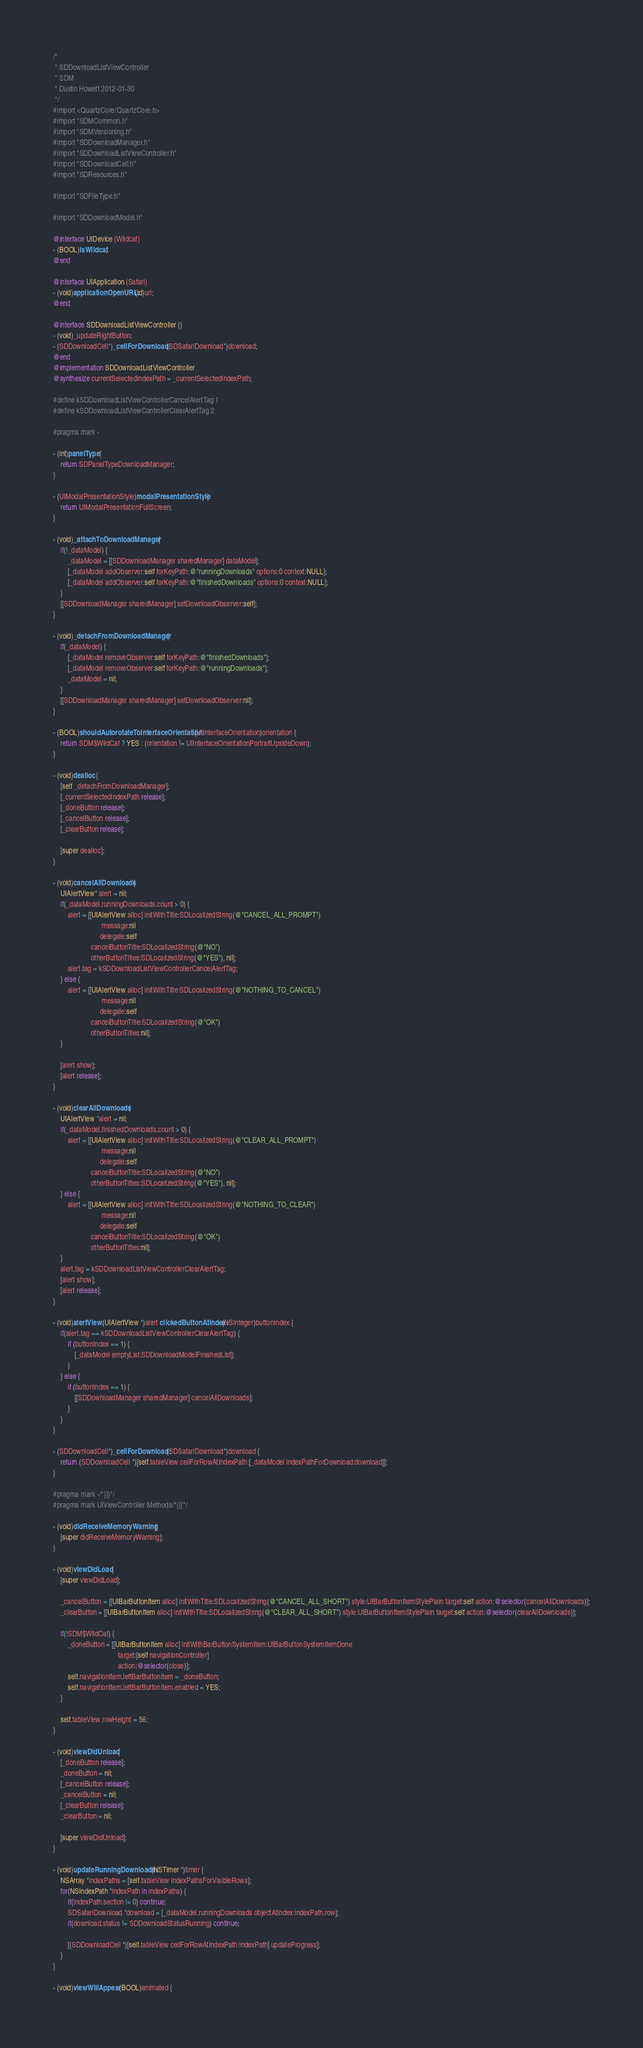Convert code to text. <code><loc_0><loc_0><loc_500><loc_500><_ObjectiveC_>/*
 * SDDownloadListViewController
 * SDM
 * Dustin Howett 2012-01-30
 */
#import <QuartzCore/QuartzCore.h>
#import "SDMCommon.h"
#import "SDMVersioning.h"
#import "SDDownloadManager.h"
#import "SDDownloadListViewController.h"
#import "SDDownloadCell.h"
#import "SDResources.h"

#import "SDFileType.h"

#import "SDDownloadModel.h"

@interface UIDevice (Wildcat)
- (BOOL)isWildcat;
@end

@interface UIApplication (Safari)
- (void)applicationOpenURL:(id)url;
@end

@interface SDDownloadListViewController ()
- (void)_updateRightButton;
- (SDDownloadCell*)_cellForDownload:(SDSafariDownload*)download;
@end
@implementation SDDownloadListViewController
@synthesize currentSelectedIndexPath = _currentSelectedIndexPath;

#define kSDDownloadListViewControllerCancelAlertTag 1
#define kSDDownloadListViewControllerClearAlertTag 2

#pragma mark -

- (int)panelType {
	return SDPanelTypeDownloadManager;
}

- (UIModalPresentationStyle)modalPresentationStyle {
	return UIModalPresentationFullScreen;
}

- (void)_attachToDownloadManager {
	if(!_dataModel) {
		_dataModel = [[SDDownloadManager sharedManager] dataModel];
		[_dataModel addObserver:self forKeyPath:@"runningDownloads" options:0 context:NULL];
		[_dataModel addObserver:self forKeyPath:@"finishedDownloads" options:0 context:NULL];
	}
	[[SDDownloadManager sharedManager] setDownloadObserver:self];
}

- (void)_detachFromDownloadManager {
	if(_dataModel) {
		[_dataModel removeObserver:self forKeyPath:@"finishedDownloads"];
		[_dataModel removeObserver:self forKeyPath:@"runningDownloads"];
		_dataModel = nil;
	}
	[[SDDownloadManager sharedManager] setDownloadObserver:nil];
}

- (BOOL)shouldAutorotateToInterfaceOrientation:(UIInterfaceOrientation)orientation {
	return SDM$WildCat ? YES : (orientation != UIInterfaceOrientationPortraitUpsideDown);
}

- (void)dealloc {
	[self _detachFromDownloadManager];
	[_currentSelectedIndexPath release];
	[_doneButton release];
	[_cancelButton release];
	[_clearButton release];

	[super dealloc];
}

- (void)cancelAllDownloads {
	UIAlertView* alert = nil;
	if(_dataModel.runningDownloads.count > 0) {
		alert = [[UIAlertView alloc] initWithTitle:SDLocalizedString(@"CANCEL_ALL_PROMPT")
						   message:nil
						  delegate:self
					 cancelButtonTitle:SDLocalizedString(@"NO")
					 otherButtonTitles:SDLocalizedString(@"YES"), nil];
		alert.tag = kSDDownloadListViewControllerCancelAlertTag;
	} else {
		alert = [[UIAlertView alloc] initWithTitle:SDLocalizedString(@"NOTHING_TO_CANCEL")
						   message:nil
						  delegate:self
					 cancelButtonTitle:SDLocalizedString(@"OK")
					 otherButtonTitles:nil];
	}
	
	[alert show];
	[alert release];
}

- (void)clearAllDownloads {
	UIAlertView *alert = nil;
	if(_dataModel.finishedDownloads.count > 0) {
		alert = [[UIAlertView alloc] initWithTitle:SDLocalizedString(@"CLEAR_ALL_PROMPT")
						   message:nil
						  delegate:self
					 cancelButtonTitle:SDLocalizedString(@"NO")
					 otherButtonTitles:SDLocalizedString(@"YES"), nil];
	} else {
		alert = [[UIAlertView alloc] initWithTitle:SDLocalizedString(@"NOTHING_TO_CLEAR")
						   message:nil
						  delegate:self
					 cancelButtonTitle:SDLocalizedString(@"OK")
					 otherButtonTitles:nil];
	}
	alert.tag = kSDDownloadListViewControllerClearAlertTag;
	[alert show];
	[alert release];
}

- (void)alertView:(UIAlertView *)alert clickedButtonAtIndex:(NSInteger)buttonIndex {
	if(alert.tag == kSDDownloadListViewControllerClearAlertTag) {
		if (buttonIndex == 1) {
			[_dataModel emptyList:SDDownloadModelFinishedList];
		}
	} else {
		if (buttonIndex == 1) {
			[[SDDownloadManager sharedManager] cancelAllDownloads];
		}
	}
}

- (SDDownloadCell*)_cellForDownload:(SDSafariDownload*)download {
	return (SDDownloadCell *)[self.tableView cellForRowAtIndexPath:[_dataModel indexPathForDownload:download]];
}

#pragma mark -/*}}}*/
#pragma mark UIViewController Methods/*{{{*/

- (void)didReceiveMemoryWarning {
	[super didReceiveMemoryWarning]; 
}

- (void)viewDidLoad {
	[super viewDidLoad];

	_cancelButton = [[UIBarButtonItem alloc] initWithTitle:SDLocalizedString(@"CANCEL_ALL_SHORT") style:UIBarButtonItemStylePlain target:self action:@selector(cancelAllDownloads)];
	_clearButton = [[UIBarButtonItem alloc] initWithTitle:SDLocalizedString(@"CLEAR_ALL_SHORT") style:UIBarButtonItemStylePlain target:self action:@selector(clearAllDownloads)];
	
	if(!SDM$WildCat) {
		_doneButton = [[UIBarButtonItem alloc] initWithBarButtonSystemItem:UIBarButtonSystemItemDone
									target:[self navigationController]
									action:@selector(close)];
		self.navigationItem.leftBarButtonItem = _doneButton;
		self.navigationItem.leftBarButtonItem.enabled = YES;
	}

	self.tableView.rowHeight = 56;
}

- (void)viewDidUnload {
	[_doneButton release];
	_doneButton = nil;
	[_cancelButton release];
	_cancelButton = nil;
	[_clearButton release];
	_clearButton = nil;

	[super viewDidUnload]; 
}

- (void)updateRunningDownloads:(NSTimer *)timer {
	NSArray *indexPaths = [self.tableView indexPathsForVisibleRows];
	for(NSIndexPath *indexPath in indexPaths) {
		if(indexPath.section != 0) continue;
		SDSafariDownload *download = [_dataModel.runningDownloads objectAtIndex:indexPath.row];
		if(download.status != SDDownloadStatusRunning) continue;

		[(SDDownloadCell *)[self.tableView cellForRowAtIndexPath:indexPath] updateProgress];
	}
}

- (void)viewWillAppear:(BOOL)animated {</code> 